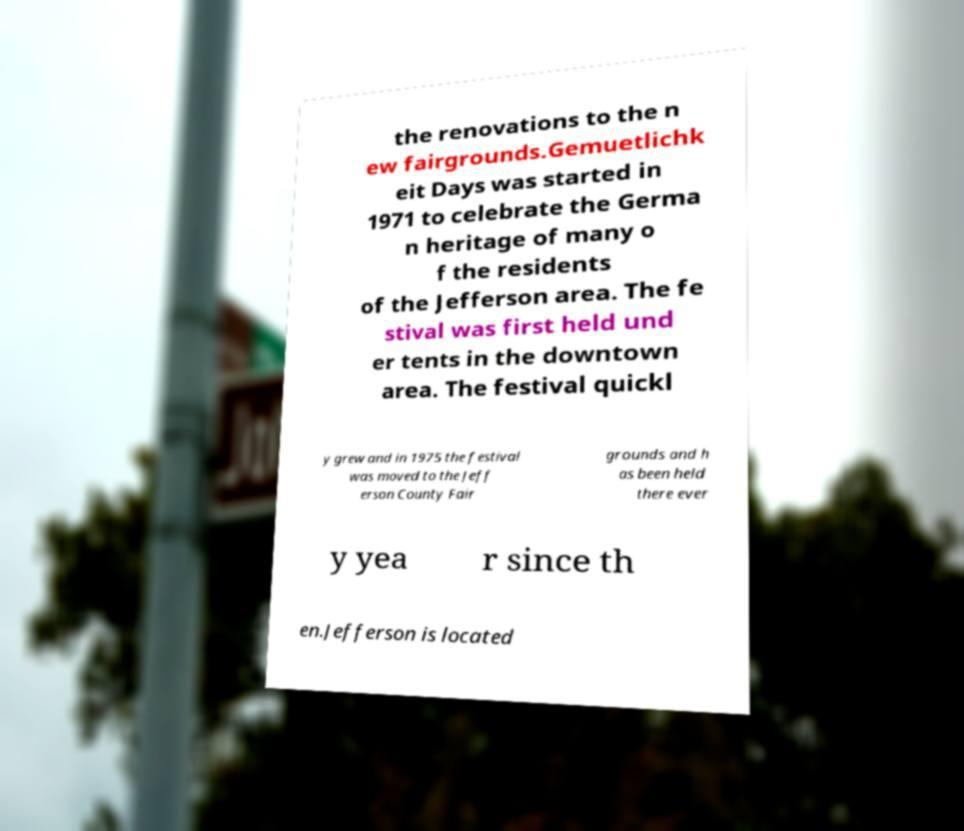Could you assist in decoding the text presented in this image and type it out clearly? the renovations to the n ew fairgrounds.Gemuetlichk eit Days was started in 1971 to celebrate the Germa n heritage of many o f the residents of the Jefferson area. The fe stival was first held und er tents in the downtown area. The festival quickl y grew and in 1975 the festival was moved to the Jeff erson County Fair grounds and h as been held there ever y yea r since th en.Jefferson is located 